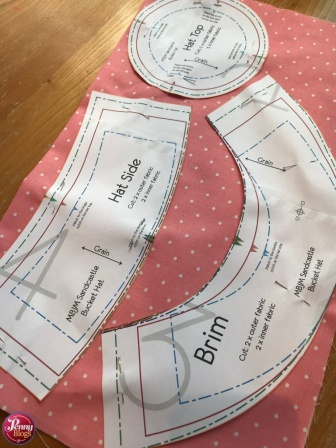Explain the visual content of the image in great detail. The image captures a vibrant scene set up for hat-making. The background features a bright pink fabric adorned with white polka dots, which serves as the base canvas. Spread out on this fabric are three distinct paper patterns, each crucial for constructing a hat.

To the left of the image, you see a pattern labeled 'Hat Side,' which is elongated and seems designed to wrap around the wearer's head, forming the main body of the hat. In the center, there's a circular pattern marked 'Crown,' which appears to be intended for the top part of the hat, providing it with shape and structure. On the right, the 'Brim' pattern is visible, characterized by its wide, curvy outline that suggests it will form the protective and decorative brim, shading the wearer.

These paper patterns, predominately white with blue lines and text, overlap slightly, adding a sense of depth to the image. This scene epitomizes a moment of meticulous planning and preparation before the creative and hands-on task of hat-making begins. It's a snapshot portraying the calm and methodical process of arranging all necessary components to create a unique piece of wearable art. 